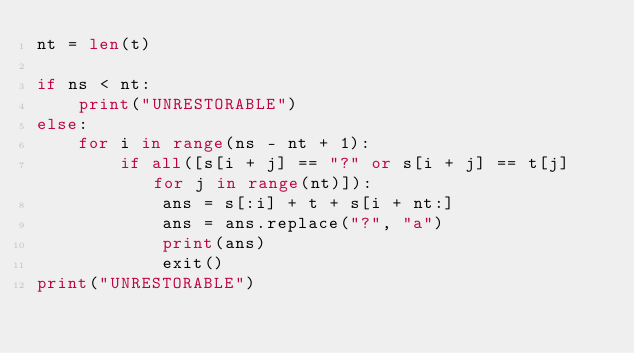<code> <loc_0><loc_0><loc_500><loc_500><_Python_>nt = len(t)

if ns < nt:
    print("UNRESTORABLE")
else:
    for i in range(ns - nt + 1):
        if all([s[i + j] == "?" or s[i + j] == t[j] for j in range(nt)]):
            ans = s[:i] + t + s[i + nt:]
            ans = ans.replace("?", "a")
            print(ans)
            exit()
print("UNRESTORABLE")</code> 